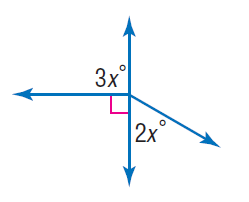Question: Find x.
Choices:
A. 30
B. 60
C. 90
D. 120
Answer with the letter. Answer: A 